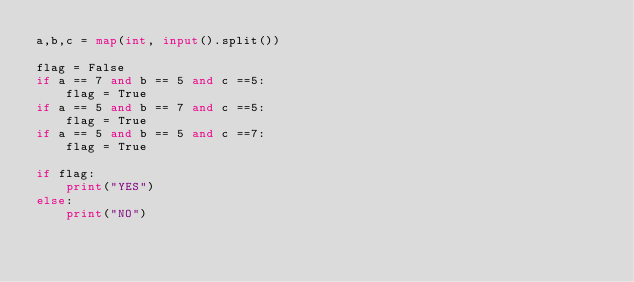<code> <loc_0><loc_0><loc_500><loc_500><_Python_>a,b,c = map(int, input().split())

flag = False
if a == 7 and b == 5 and c ==5:
    flag = True
if a == 5 and b == 7 and c ==5:
    flag = True
if a == 5 and b == 5 and c ==7:
    flag = True

if flag:
    print("YES")
else:
    print("NO")</code> 